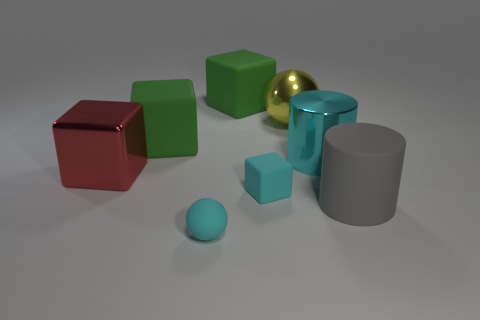Subtract all blue blocks. Subtract all cyan cylinders. How many blocks are left? 4 Add 2 large cyan shiny objects. How many objects exist? 10 Subtract all big metal cylinders. Subtract all gray matte objects. How many objects are left? 6 Add 3 large rubber objects. How many large rubber objects are left? 6 Add 7 large red rubber balls. How many large red rubber balls exist? 7 Subtract 0 gray blocks. How many objects are left? 8 